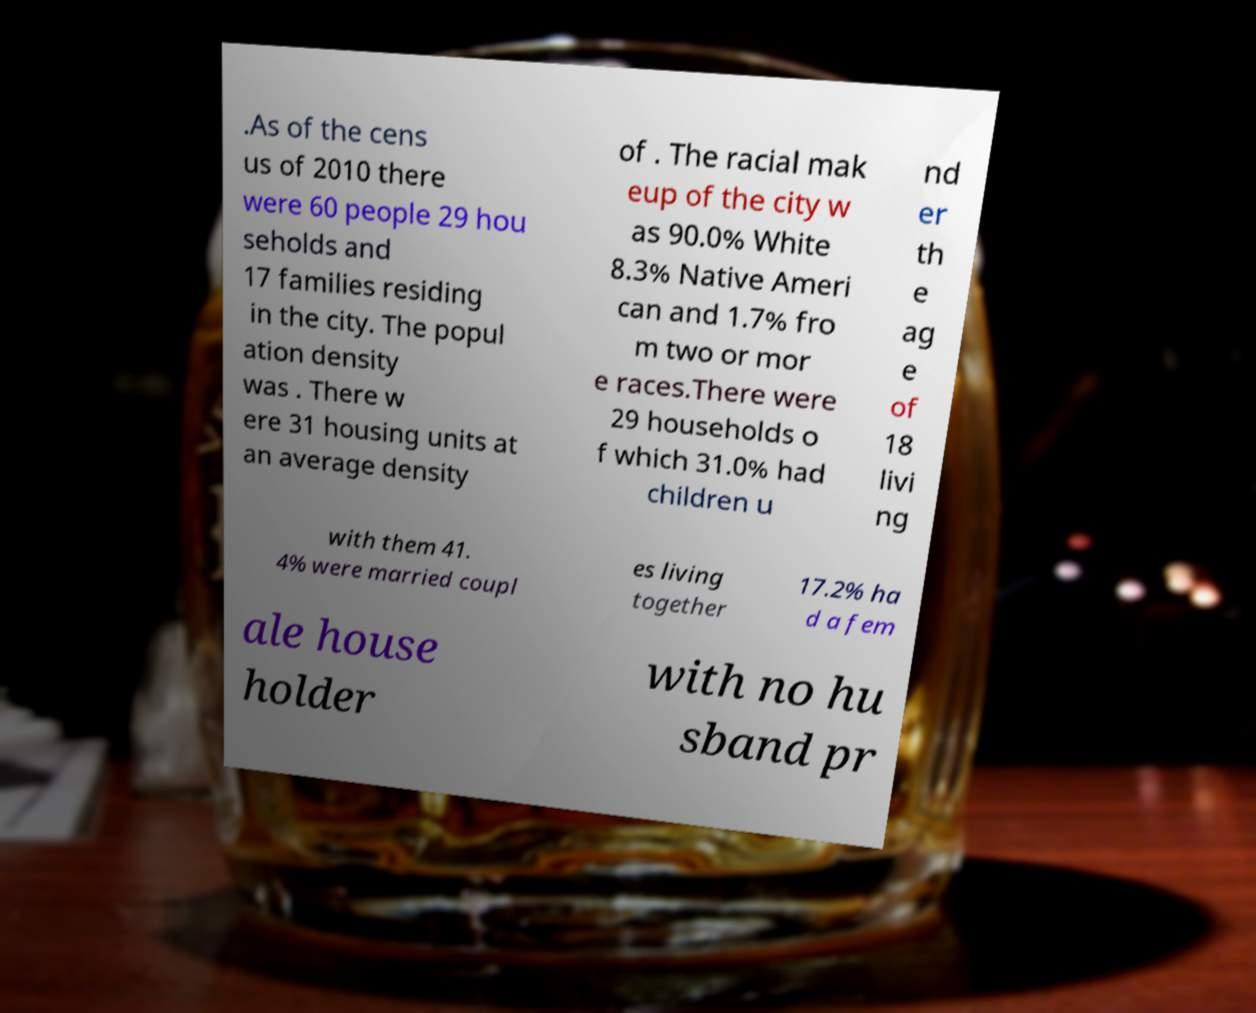I need the written content from this picture converted into text. Can you do that? .As of the cens us of 2010 there were 60 people 29 hou seholds and 17 families residing in the city. The popul ation density was . There w ere 31 housing units at an average density of . The racial mak eup of the city w as 90.0% White 8.3% Native Ameri can and 1.7% fro m two or mor e races.There were 29 households o f which 31.0% had children u nd er th e ag e of 18 livi ng with them 41. 4% were married coupl es living together 17.2% ha d a fem ale house holder with no hu sband pr 